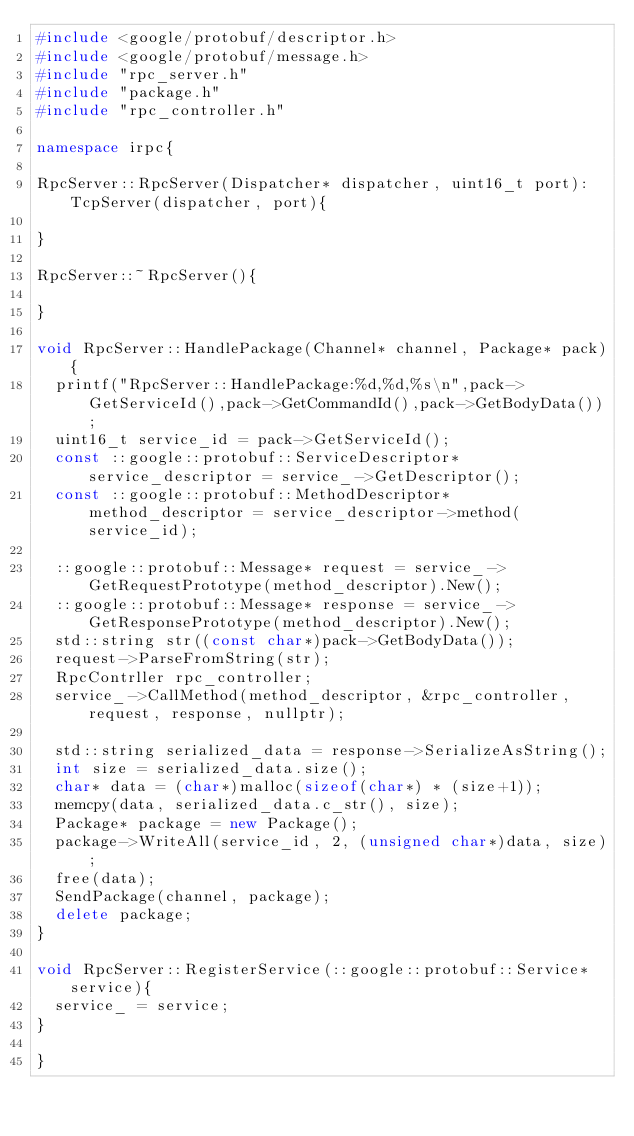Convert code to text. <code><loc_0><loc_0><loc_500><loc_500><_C++_>#include <google/protobuf/descriptor.h>
#include <google/protobuf/message.h>
#include "rpc_server.h"
#include "package.h"
#include "rpc_controller.h"

namespace irpc{

RpcServer::RpcServer(Dispatcher* dispatcher, uint16_t port):TcpServer(dispatcher, port){

}

RpcServer::~RpcServer(){

}

void RpcServer::HandlePackage(Channel* channel, Package* pack){
	printf("RpcServer::HandlePackage:%d,%d,%s\n",pack->GetServiceId(),pack->GetCommandId(),pack->GetBodyData());
	uint16_t service_id = pack->GetServiceId();
	const ::google::protobuf::ServiceDescriptor* service_descriptor = service_->GetDescriptor();
	const ::google::protobuf::MethodDescriptor* method_descriptor = service_descriptor->method(service_id);
	
	::google::protobuf::Message* request = service_->GetRequestPrototype(method_descriptor).New();
	::google::protobuf::Message* response = service_->GetResponsePrototype(method_descriptor).New();
	std::string str((const char*)pack->GetBodyData());
	request->ParseFromString(str);
	RpcContrller rpc_controller;
	service_->CallMethod(method_descriptor, &rpc_controller, request, response, nullptr);

	std::string serialized_data = response->SerializeAsString();
	int size = serialized_data.size();
	char* data = (char*)malloc(sizeof(char*) * (size+1));
	memcpy(data, serialized_data.c_str(), size);
	Package* package = new Package();
	package->WriteAll(service_id, 2, (unsigned char*)data, size);
	free(data);
	SendPackage(channel, package);
	delete package;
}

void RpcServer::RegisterService(::google::protobuf::Service* service){
	service_ = service;
}

}</code> 